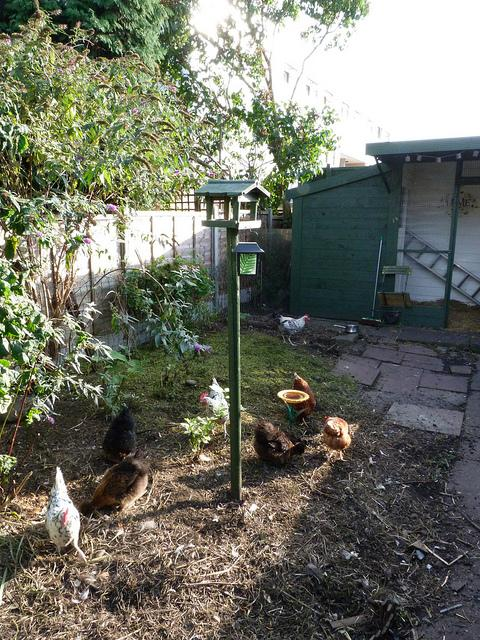How many spotted white chickens are there?

Choices:
A) three
B) one
C) two
D) four three 